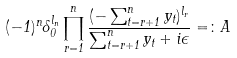Convert formula to latex. <formula><loc_0><loc_0><loc_500><loc_500>( - 1 ) ^ { n } \delta _ { 0 } ^ { l _ { n } } \prod _ { r = 1 } ^ { n } \frac { ( - \sum _ { t = r + 1 } ^ { n } y _ { t } ) ^ { l _ { r } } } { \sum _ { t = r + 1 } ^ { n } y _ { t } + i \epsilon } = \colon A</formula> 